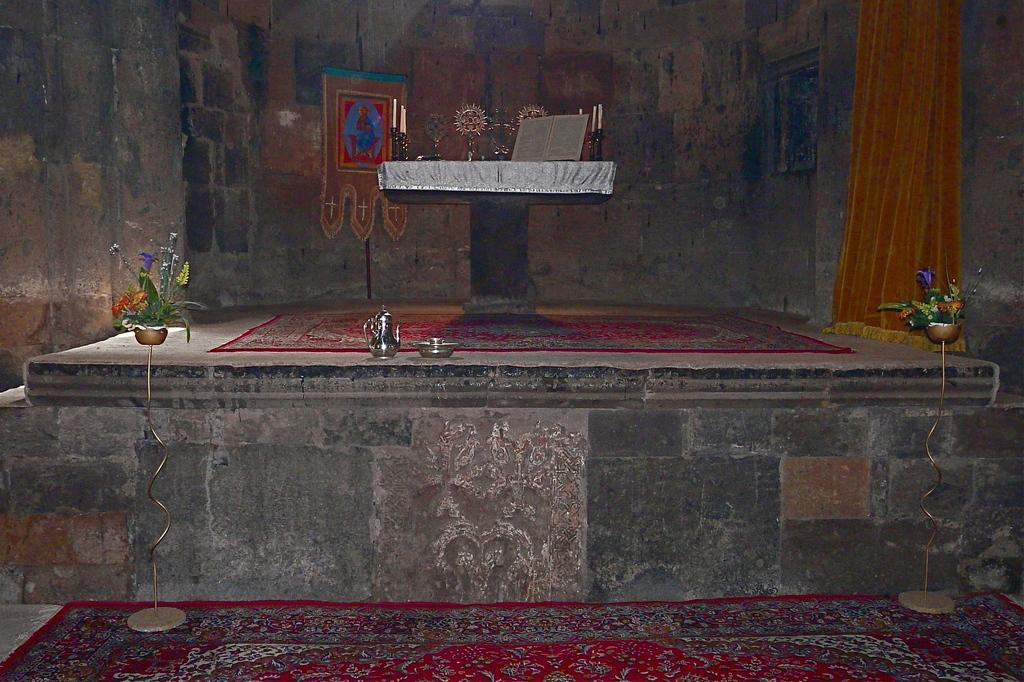What is located in the foreground of the image? There is a stage, a bowl, a houseplant, and a table in the foreground of the image. What can be found on the table in the image? Trophies are present on the table in the image. What is visible on the wall in the image? There is a wall painting on the wall in the image. What type of window treatment is present in the image? There is a curtain in the image. In which type of space was the image taken? The image was taken in a hall. What type of noise can be heard coming from the box in the middle of the image? There is no box present in the image, and therefore no such noise can be heard. 